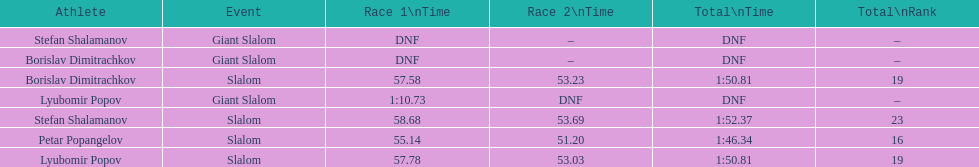What is the difference in time for petar popangelov in race 1and 2 3.94. 